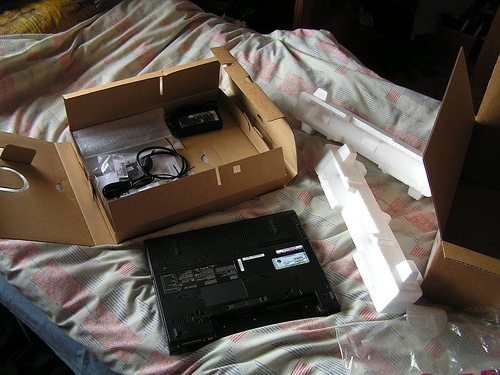Describe the objects in this image and their specific colors. I can see bed in black, gray, darkgray, and maroon tones and laptop in black, gray, darkgray, and lightgray tones in this image. 